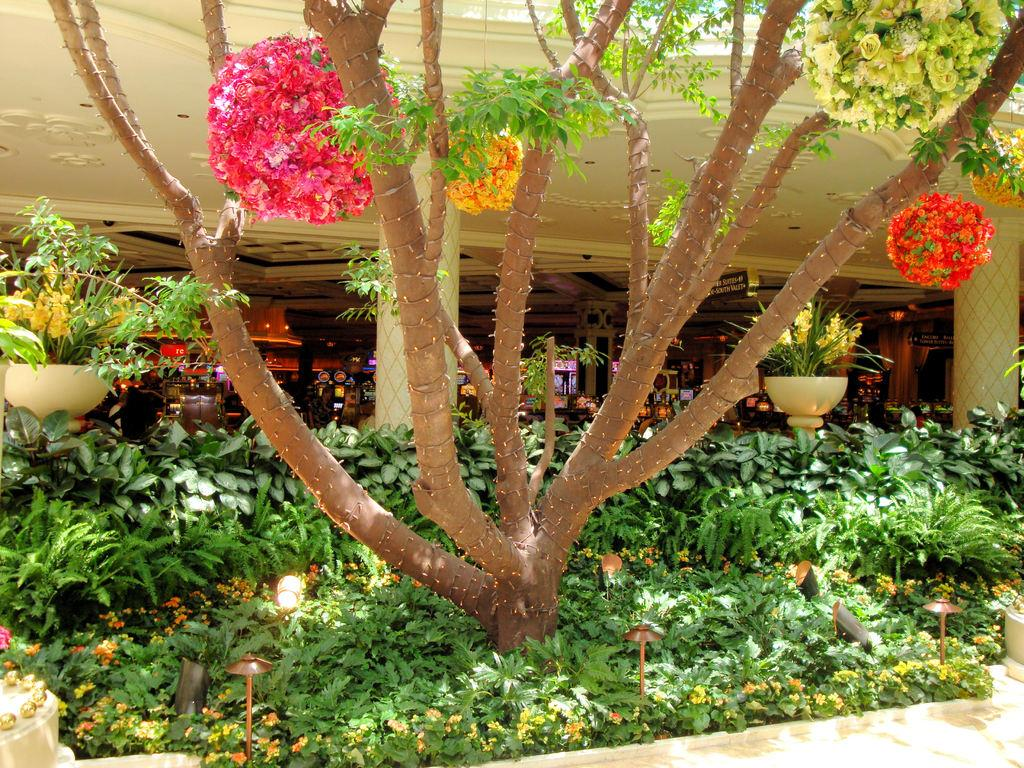What is located in the center of the picture? In the center of the picture, there are plants, flowers, a tree, lights, and other objects. Can you describe the objects in the center of the picture? The objects in the center of the picture include plants, flowers, a tree, and lights. What is visible in the background of the picture? In the background of the picture, there is a building. What can be found inside the building? Inside the building, there are shops. What type of whip can be seen hanging from the tree in the image? There is no whip present in the image; it features plants, flowers, a tree, and lights in the center, with a building in the background. What kind of leather goods are visible in the image? There is no leather or leather goods present in the image. 